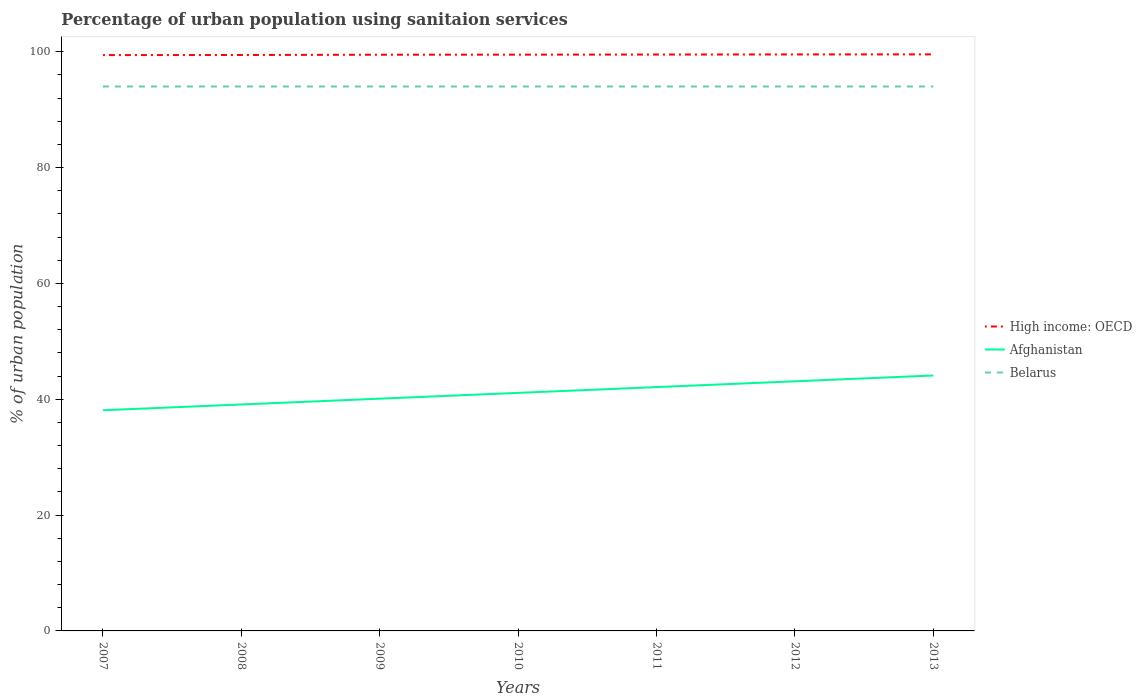Does the line corresponding to Afghanistan intersect with the line corresponding to High income: OECD?
Your response must be concise. No. Across all years, what is the maximum percentage of urban population using sanitaion services in Belarus?
Your answer should be very brief. 94. In which year was the percentage of urban population using sanitaion services in Afghanistan maximum?
Keep it short and to the point. 2007. What is the difference between the highest and the second highest percentage of urban population using sanitaion services in Afghanistan?
Your answer should be very brief. 6. Is the percentage of urban population using sanitaion services in Afghanistan strictly greater than the percentage of urban population using sanitaion services in Belarus over the years?
Your response must be concise. Yes. How many lines are there?
Your response must be concise. 3. How many years are there in the graph?
Give a very brief answer. 7. What is the difference between two consecutive major ticks on the Y-axis?
Provide a short and direct response. 20. Are the values on the major ticks of Y-axis written in scientific E-notation?
Give a very brief answer. No. Does the graph contain grids?
Provide a succinct answer. No. How many legend labels are there?
Your answer should be very brief. 3. What is the title of the graph?
Your answer should be very brief. Percentage of urban population using sanitaion services. What is the label or title of the Y-axis?
Ensure brevity in your answer.  % of urban population. What is the % of urban population in High income: OECD in 2007?
Make the answer very short. 99.42. What is the % of urban population in Afghanistan in 2007?
Make the answer very short. 38.1. What is the % of urban population in Belarus in 2007?
Ensure brevity in your answer.  94. What is the % of urban population in High income: OECD in 2008?
Your answer should be compact. 99.44. What is the % of urban population of Afghanistan in 2008?
Provide a succinct answer. 39.1. What is the % of urban population of Belarus in 2008?
Make the answer very short. 94. What is the % of urban population of High income: OECD in 2009?
Provide a short and direct response. 99.49. What is the % of urban population of Afghanistan in 2009?
Provide a succinct answer. 40.1. What is the % of urban population in Belarus in 2009?
Give a very brief answer. 94. What is the % of urban population of High income: OECD in 2010?
Provide a succinct answer. 99.5. What is the % of urban population in Afghanistan in 2010?
Keep it short and to the point. 41.1. What is the % of urban population of Belarus in 2010?
Give a very brief answer. 94. What is the % of urban population of High income: OECD in 2011?
Offer a terse response. 99.52. What is the % of urban population of Afghanistan in 2011?
Your answer should be very brief. 42.1. What is the % of urban population of Belarus in 2011?
Keep it short and to the point. 94. What is the % of urban population in High income: OECD in 2012?
Offer a very short reply. 99.54. What is the % of urban population of Afghanistan in 2012?
Your answer should be compact. 43.1. What is the % of urban population of Belarus in 2012?
Ensure brevity in your answer.  94. What is the % of urban population of High income: OECD in 2013?
Provide a succinct answer. 99.55. What is the % of urban population of Afghanistan in 2013?
Offer a terse response. 44.1. What is the % of urban population of Belarus in 2013?
Your answer should be very brief. 94. Across all years, what is the maximum % of urban population in High income: OECD?
Your response must be concise. 99.55. Across all years, what is the maximum % of urban population of Afghanistan?
Give a very brief answer. 44.1. Across all years, what is the maximum % of urban population of Belarus?
Provide a short and direct response. 94. Across all years, what is the minimum % of urban population of High income: OECD?
Provide a short and direct response. 99.42. Across all years, what is the minimum % of urban population in Afghanistan?
Provide a short and direct response. 38.1. Across all years, what is the minimum % of urban population in Belarus?
Your answer should be very brief. 94. What is the total % of urban population of High income: OECD in the graph?
Ensure brevity in your answer.  696.45. What is the total % of urban population of Afghanistan in the graph?
Offer a very short reply. 287.7. What is the total % of urban population in Belarus in the graph?
Your response must be concise. 658. What is the difference between the % of urban population of High income: OECD in 2007 and that in 2008?
Your answer should be very brief. -0.02. What is the difference between the % of urban population in High income: OECD in 2007 and that in 2009?
Provide a succinct answer. -0.07. What is the difference between the % of urban population in Afghanistan in 2007 and that in 2009?
Keep it short and to the point. -2. What is the difference between the % of urban population in High income: OECD in 2007 and that in 2010?
Keep it short and to the point. -0.08. What is the difference between the % of urban population of Afghanistan in 2007 and that in 2010?
Offer a terse response. -3. What is the difference between the % of urban population in High income: OECD in 2007 and that in 2011?
Offer a terse response. -0.1. What is the difference between the % of urban population of Afghanistan in 2007 and that in 2011?
Make the answer very short. -4. What is the difference between the % of urban population of High income: OECD in 2007 and that in 2012?
Give a very brief answer. -0.12. What is the difference between the % of urban population in High income: OECD in 2007 and that in 2013?
Your response must be concise. -0.13. What is the difference between the % of urban population of Afghanistan in 2007 and that in 2013?
Give a very brief answer. -6. What is the difference between the % of urban population in Belarus in 2007 and that in 2013?
Make the answer very short. 0. What is the difference between the % of urban population of High income: OECD in 2008 and that in 2009?
Provide a short and direct response. -0.05. What is the difference between the % of urban population of High income: OECD in 2008 and that in 2010?
Provide a short and direct response. -0.06. What is the difference between the % of urban population in Afghanistan in 2008 and that in 2010?
Make the answer very short. -2. What is the difference between the % of urban population of Belarus in 2008 and that in 2010?
Your answer should be compact. 0. What is the difference between the % of urban population in High income: OECD in 2008 and that in 2011?
Provide a short and direct response. -0.08. What is the difference between the % of urban population in Afghanistan in 2008 and that in 2011?
Your response must be concise. -3. What is the difference between the % of urban population of High income: OECD in 2008 and that in 2012?
Your response must be concise. -0.1. What is the difference between the % of urban population of High income: OECD in 2008 and that in 2013?
Provide a succinct answer. -0.11. What is the difference between the % of urban population of High income: OECD in 2009 and that in 2010?
Provide a short and direct response. -0.02. What is the difference between the % of urban population in High income: OECD in 2009 and that in 2011?
Your response must be concise. -0.04. What is the difference between the % of urban population in Belarus in 2009 and that in 2011?
Your answer should be compact. 0. What is the difference between the % of urban population of High income: OECD in 2009 and that in 2012?
Provide a short and direct response. -0.05. What is the difference between the % of urban population in Afghanistan in 2009 and that in 2012?
Keep it short and to the point. -3. What is the difference between the % of urban population in Belarus in 2009 and that in 2012?
Your response must be concise. 0. What is the difference between the % of urban population in High income: OECD in 2009 and that in 2013?
Offer a terse response. -0.06. What is the difference between the % of urban population in Afghanistan in 2009 and that in 2013?
Offer a very short reply. -4. What is the difference between the % of urban population in High income: OECD in 2010 and that in 2011?
Keep it short and to the point. -0.02. What is the difference between the % of urban population of High income: OECD in 2010 and that in 2012?
Your response must be concise. -0.04. What is the difference between the % of urban population in Afghanistan in 2010 and that in 2012?
Offer a very short reply. -2. What is the difference between the % of urban population of High income: OECD in 2010 and that in 2013?
Offer a very short reply. -0.05. What is the difference between the % of urban population in Afghanistan in 2010 and that in 2013?
Offer a terse response. -3. What is the difference between the % of urban population of High income: OECD in 2011 and that in 2012?
Provide a succinct answer. -0.02. What is the difference between the % of urban population in Afghanistan in 2011 and that in 2012?
Offer a very short reply. -1. What is the difference between the % of urban population of Belarus in 2011 and that in 2012?
Ensure brevity in your answer.  0. What is the difference between the % of urban population of High income: OECD in 2011 and that in 2013?
Provide a succinct answer. -0.03. What is the difference between the % of urban population in Afghanistan in 2011 and that in 2013?
Provide a short and direct response. -2. What is the difference between the % of urban population of High income: OECD in 2012 and that in 2013?
Offer a terse response. -0.01. What is the difference between the % of urban population of Afghanistan in 2012 and that in 2013?
Your answer should be compact. -1. What is the difference between the % of urban population of High income: OECD in 2007 and the % of urban population of Afghanistan in 2008?
Give a very brief answer. 60.32. What is the difference between the % of urban population of High income: OECD in 2007 and the % of urban population of Belarus in 2008?
Your answer should be very brief. 5.42. What is the difference between the % of urban population in Afghanistan in 2007 and the % of urban population in Belarus in 2008?
Provide a succinct answer. -55.9. What is the difference between the % of urban population of High income: OECD in 2007 and the % of urban population of Afghanistan in 2009?
Your answer should be compact. 59.32. What is the difference between the % of urban population of High income: OECD in 2007 and the % of urban population of Belarus in 2009?
Your answer should be compact. 5.42. What is the difference between the % of urban population in Afghanistan in 2007 and the % of urban population in Belarus in 2009?
Your answer should be compact. -55.9. What is the difference between the % of urban population in High income: OECD in 2007 and the % of urban population in Afghanistan in 2010?
Provide a short and direct response. 58.32. What is the difference between the % of urban population of High income: OECD in 2007 and the % of urban population of Belarus in 2010?
Provide a short and direct response. 5.42. What is the difference between the % of urban population in Afghanistan in 2007 and the % of urban population in Belarus in 2010?
Ensure brevity in your answer.  -55.9. What is the difference between the % of urban population of High income: OECD in 2007 and the % of urban population of Afghanistan in 2011?
Make the answer very short. 57.32. What is the difference between the % of urban population in High income: OECD in 2007 and the % of urban population in Belarus in 2011?
Offer a very short reply. 5.42. What is the difference between the % of urban population of Afghanistan in 2007 and the % of urban population of Belarus in 2011?
Offer a terse response. -55.9. What is the difference between the % of urban population of High income: OECD in 2007 and the % of urban population of Afghanistan in 2012?
Give a very brief answer. 56.32. What is the difference between the % of urban population of High income: OECD in 2007 and the % of urban population of Belarus in 2012?
Keep it short and to the point. 5.42. What is the difference between the % of urban population in Afghanistan in 2007 and the % of urban population in Belarus in 2012?
Give a very brief answer. -55.9. What is the difference between the % of urban population of High income: OECD in 2007 and the % of urban population of Afghanistan in 2013?
Offer a very short reply. 55.32. What is the difference between the % of urban population in High income: OECD in 2007 and the % of urban population in Belarus in 2013?
Offer a very short reply. 5.42. What is the difference between the % of urban population in Afghanistan in 2007 and the % of urban population in Belarus in 2013?
Provide a short and direct response. -55.9. What is the difference between the % of urban population of High income: OECD in 2008 and the % of urban population of Afghanistan in 2009?
Keep it short and to the point. 59.34. What is the difference between the % of urban population of High income: OECD in 2008 and the % of urban population of Belarus in 2009?
Provide a succinct answer. 5.44. What is the difference between the % of urban population of Afghanistan in 2008 and the % of urban population of Belarus in 2009?
Provide a succinct answer. -54.9. What is the difference between the % of urban population of High income: OECD in 2008 and the % of urban population of Afghanistan in 2010?
Your answer should be very brief. 58.34. What is the difference between the % of urban population of High income: OECD in 2008 and the % of urban population of Belarus in 2010?
Provide a succinct answer. 5.44. What is the difference between the % of urban population of Afghanistan in 2008 and the % of urban population of Belarus in 2010?
Offer a terse response. -54.9. What is the difference between the % of urban population in High income: OECD in 2008 and the % of urban population in Afghanistan in 2011?
Your response must be concise. 57.34. What is the difference between the % of urban population of High income: OECD in 2008 and the % of urban population of Belarus in 2011?
Your answer should be very brief. 5.44. What is the difference between the % of urban population in Afghanistan in 2008 and the % of urban population in Belarus in 2011?
Your answer should be compact. -54.9. What is the difference between the % of urban population of High income: OECD in 2008 and the % of urban population of Afghanistan in 2012?
Keep it short and to the point. 56.34. What is the difference between the % of urban population of High income: OECD in 2008 and the % of urban population of Belarus in 2012?
Your response must be concise. 5.44. What is the difference between the % of urban population of Afghanistan in 2008 and the % of urban population of Belarus in 2012?
Provide a short and direct response. -54.9. What is the difference between the % of urban population of High income: OECD in 2008 and the % of urban population of Afghanistan in 2013?
Provide a short and direct response. 55.34. What is the difference between the % of urban population in High income: OECD in 2008 and the % of urban population in Belarus in 2013?
Make the answer very short. 5.44. What is the difference between the % of urban population of Afghanistan in 2008 and the % of urban population of Belarus in 2013?
Your answer should be very brief. -54.9. What is the difference between the % of urban population in High income: OECD in 2009 and the % of urban population in Afghanistan in 2010?
Keep it short and to the point. 58.39. What is the difference between the % of urban population in High income: OECD in 2009 and the % of urban population in Belarus in 2010?
Keep it short and to the point. 5.49. What is the difference between the % of urban population of Afghanistan in 2009 and the % of urban population of Belarus in 2010?
Provide a succinct answer. -53.9. What is the difference between the % of urban population in High income: OECD in 2009 and the % of urban population in Afghanistan in 2011?
Ensure brevity in your answer.  57.39. What is the difference between the % of urban population of High income: OECD in 2009 and the % of urban population of Belarus in 2011?
Make the answer very short. 5.49. What is the difference between the % of urban population of Afghanistan in 2009 and the % of urban population of Belarus in 2011?
Offer a very short reply. -53.9. What is the difference between the % of urban population of High income: OECD in 2009 and the % of urban population of Afghanistan in 2012?
Provide a short and direct response. 56.39. What is the difference between the % of urban population of High income: OECD in 2009 and the % of urban population of Belarus in 2012?
Ensure brevity in your answer.  5.49. What is the difference between the % of urban population of Afghanistan in 2009 and the % of urban population of Belarus in 2012?
Ensure brevity in your answer.  -53.9. What is the difference between the % of urban population in High income: OECD in 2009 and the % of urban population in Afghanistan in 2013?
Give a very brief answer. 55.39. What is the difference between the % of urban population in High income: OECD in 2009 and the % of urban population in Belarus in 2013?
Your answer should be compact. 5.49. What is the difference between the % of urban population of Afghanistan in 2009 and the % of urban population of Belarus in 2013?
Make the answer very short. -53.9. What is the difference between the % of urban population in High income: OECD in 2010 and the % of urban population in Afghanistan in 2011?
Your answer should be compact. 57.4. What is the difference between the % of urban population of High income: OECD in 2010 and the % of urban population of Belarus in 2011?
Provide a short and direct response. 5.5. What is the difference between the % of urban population of Afghanistan in 2010 and the % of urban population of Belarus in 2011?
Your answer should be compact. -52.9. What is the difference between the % of urban population in High income: OECD in 2010 and the % of urban population in Afghanistan in 2012?
Give a very brief answer. 56.4. What is the difference between the % of urban population of High income: OECD in 2010 and the % of urban population of Belarus in 2012?
Give a very brief answer. 5.5. What is the difference between the % of urban population in Afghanistan in 2010 and the % of urban population in Belarus in 2012?
Make the answer very short. -52.9. What is the difference between the % of urban population of High income: OECD in 2010 and the % of urban population of Afghanistan in 2013?
Offer a terse response. 55.4. What is the difference between the % of urban population in High income: OECD in 2010 and the % of urban population in Belarus in 2013?
Give a very brief answer. 5.5. What is the difference between the % of urban population of Afghanistan in 2010 and the % of urban population of Belarus in 2013?
Provide a short and direct response. -52.9. What is the difference between the % of urban population of High income: OECD in 2011 and the % of urban population of Afghanistan in 2012?
Your response must be concise. 56.42. What is the difference between the % of urban population in High income: OECD in 2011 and the % of urban population in Belarus in 2012?
Keep it short and to the point. 5.52. What is the difference between the % of urban population in Afghanistan in 2011 and the % of urban population in Belarus in 2012?
Ensure brevity in your answer.  -51.9. What is the difference between the % of urban population in High income: OECD in 2011 and the % of urban population in Afghanistan in 2013?
Offer a terse response. 55.42. What is the difference between the % of urban population of High income: OECD in 2011 and the % of urban population of Belarus in 2013?
Give a very brief answer. 5.52. What is the difference between the % of urban population of Afghanistan in 2011 and the % of urban population of Belarus in 2013?
Ensure brevity in your answer.  -51.9. What is the difference between the % of urban population in High income: OECD in 2012 and the % of urban population in Afghanistan in 2013?
Provide a short and direct response. 55.44. What is the difference between the % of urban population of High income: OECD in 2012 and the % of urban population of Belarus in 2013?
Provide a short and direct response. 5.54. What is the difference between the % of urban population in Afghanistan in 2012 and the % of urban population in Belarus in 2013?
Your answer should be very brief. -50.9. What is the average % of urban population of High income: OECD per year?
Your answer should be compact. 99.49. What is the average % of urban population in Afghanistan per year?
Ensure brevity in your answer.  41.1. What is the average % of urban population of Belarus per year?
Your answer should be very brief. 94. In the year 2007, what is the difference between the % of urban population in High income: OECD and % of urban population in Afghanistan?
Offer a terse response. 61.32. In the year 2007, what is the difference between the % of urban population of High income: OECD and % of urban population of Belarus?
Your response must be concise. 5.42. In the year 2007, what is the difference between the % of urban population of Afghanistan and % of urban population of Belarus?
Make the answer very short. -55.9. In the year 2008, what is the difference between the % of urban population in High income: OECD and % of urban population in Afghanistan?
Offer a terse response. 60.34. In the year 2008, what is the difference between the % of urban population of High income: OECD and % of urban population of Belarus?
Offer a terse response. 5.44. In the year 2008, what is the difference between the % of urban population of Afghanistan and % of urban population of Belarus?
Offer a very short reply. -54.9. In the year 2009, what is the difference between the % of urban population of High income: OECD and % of urban population of Afghanistan?
Offer a terse response. 59.39. In the year 2009, what is the difference between the % of urban population in High income: OECD and % of urban population in Belarus?
Ensure brevity in your answer.  5.49. In the year 2009, what is the difference between the % of urban population of Afghanistan and % of urban population of Belarus?
Your answer should be very brief. -53.9. In the year 2010, what is the difference between the % of urban population in High income: OECD and % of urban population in Afghanistan?
Offer a very short reply. 58.4. In the year 2010, what is the difference between the % of urban population of High income: OECD and % of urban population of Belarus?
Provide a short and direct response. 5.5. In the year 2010, what is the difference between the % of urban population in Afghanistan and % of urban population in Belarus?
Your response must be concise. -52.9. In the year 2011, what is the difference between the % of urban population of High income: OECD and % of urban population of Afghanistan?
Provide a short and direct response. 57.42. In the year 2011, what is the difference between the % of urban population in High income: OECD and % of urban population in Belarus?
Your response must be concise. 5.52. In the year 2011, what is the difference between the % of urban population of Afghanistan and % of urban population of Belarus?
Provide a succinct answer. -51.9. In the year 2012, what is the difference between the % of urban population of High income: OECD and % of urban population of Afghanistan?
Offer a very short reply. 56.44. In the year 2012, what is the difference between the % of urban population in High income: OECD and % of urban population in Belarus?
Keep it short and to the point. 5.54. In the year 2012, what is the difference between the % of urban population of Afghanistan and % of urban population of Belarus?
Your answer should be compact. -50.9. In the year 2013, what is the difference between the % of urban population in High income: OECD and % of urban population in Afghanistan?
Your answer should be compact. 55.45. In the year 2013, what is the difference between the % of urban population in High income: OECD and % of urban population in Belarus?
Give a very brief answer. 5.55. In the year 2013, what is the difference between the % of urban population in Afghanistan and % of urban population in Belarus?
Provide a succinct answer. -49.9. What is the ratio of the % of urban population in High income: OECD in 2007 to that in 2008?
Keep it short and to the point. 1. What is the ratio of the % of urban population of Afghanistan in 2007 to that in 2008?
Your response must be concise. 0.97. What is the ratio of the % of urban population of High income: OECD in 2007 to that in 2009?
Offer a very short reply. 1. What is the ratio of the % of urban population of Afghanistan in 2007 to that in 2009?
Keep it short and to the point. 0.95. What is the ratio of the % of urban population of Afghanistan in 2007 to that in 2010?
Give a very brief answer. 0.93. What is the ratio of the % of urban population in Belarus in 2007 to that in 2010?
Give a very brief answer. 1. What is the ratio of the % of urban population in High income: OECD in 2007 to that in 2011?
Offer a very short reply. 1. What is the ratio of the % of urban population in Afghanistan in 2007 to that in 2011?
Your answer should be compact. 0.91. What is the ratio of the % of urban population in High income: OECD in 2007 to that in 2012?
Offer a very short reply. 1. What is the ratio of the % of urban population in Afghanistan in 2007 to that in 2012?
Provide a succinct answer. 0.88. What is the ratio of the % of urban population of Afghanistan in 2007 to that in 2013?
Your response must be concise. 0.86. What is the ratio of the % of urban population in Afghanistan in 2008 to that in 2009?
Give a very brief answer. 0.98. What is the ratio of the % of urban population of Belarus in 2008 to that in 2009?
Provide a short and direct response. 1. What is the ratio of the % of urban population in Afghanistan in 2008 to that in 2010?
Provide a succinct answer. 0.95. What is the ratio of the % of urban population in Afghanistan in 2008 to that in 2011?
Provide a short and direct response. 0.93. What is the ratio of the % of urban population in Afghanistan in 2008 to that in 2012?
Your response must be concise. 0.91. What is the ratio of the % of urban population of High income: OECD in 2008 to that in 2013?
Ensure brevity in your answer.  1. What is the ratio of the % of urban population in Afghanistan in 2008 to that in 2013?
Give a very brief answer. 0.89. What is the ratio of the % of urban population in High income: OECD in 2009 to that in 2010?
Ensure brevity in your answer.  1. What is the ratio of the % of urban population of Afghanistan in 2009 to that in 2010?
Provide a short and direct response. 0.98. What is the ratio of the % of urban population in Belarus in 2009 to that in 2010?
Your answer should be very brief. 1. What is the ratio of the % of urban population in Afghanistan in 2009 to that in 2011?
Provide a short and direct response. 0.95. What is the ratio of the % of urban population of Afghanistan in 2009 to that in 2012?
Provide a short and direct response. 0.93. What is the ratio of the % of urban population of Belarus in 2009 to that in 2012?
Your response must be concise. 1. What is the ratio of the % of urban population in Afghanistan in 2009 to that in 2013?
Provide a short and direct response. 0.91. What is the ratio of the % of urban population of High income: OECD in 2010 to that in 2011?
Make the answer very short. 1. What is the ratio of the % of urban population of Afghanistan in 2010 to that in 2011?
Provide a succinct answer. 0.98. What is the ratio of the % of urban population in Afghanistan in 2010 to that in 2012?
Give a very brief answer. 0.95. What is the ratio of the % of urban population in Belarus in 2010 to that in 2012?
Your answer should be very brief. 1. What is the ratio of the % of urban population of Afghanistan in 2010 to that in 2013?
Your answer should be compact. 0.93. What is the ratio of the % of urban population in Afghanistan in 2011 to that in 2012?
Your response must be concise. 0.98. What is the ratio of the % of urban population of High income: OECD in 2011 to that in 2013?
Give a very brief answer. 1. What is the ratio of the % of urban population in Afghanistan in 2011 to that in 2013?
Your answer should be very brief. 0.95. What is the ratio of the % of urban population in High income: OECD in 2012 to that in 2013?
Ensure brevity in your answer.  1. What is the ratio of the % of urban population of Afghanistan in 2012 to that in 2013?
Your response must be concise. 0.98. What is the ratio of the % of urban population in Belarus in 2012 to that in 2013?
Ensure brevity in your answer.  1. What is the difference between the highest and the second highest % of urban population of High income: OECD?
Keep it short and to the point. 0.01. What is the difference between the highest and the second highest % of urban population in Afghanistan?
Offer a very short reply. 1. What is the difference between the highest and the lowest % of urban population in High income: OECD?
Offer a very short reply. 0.13. 